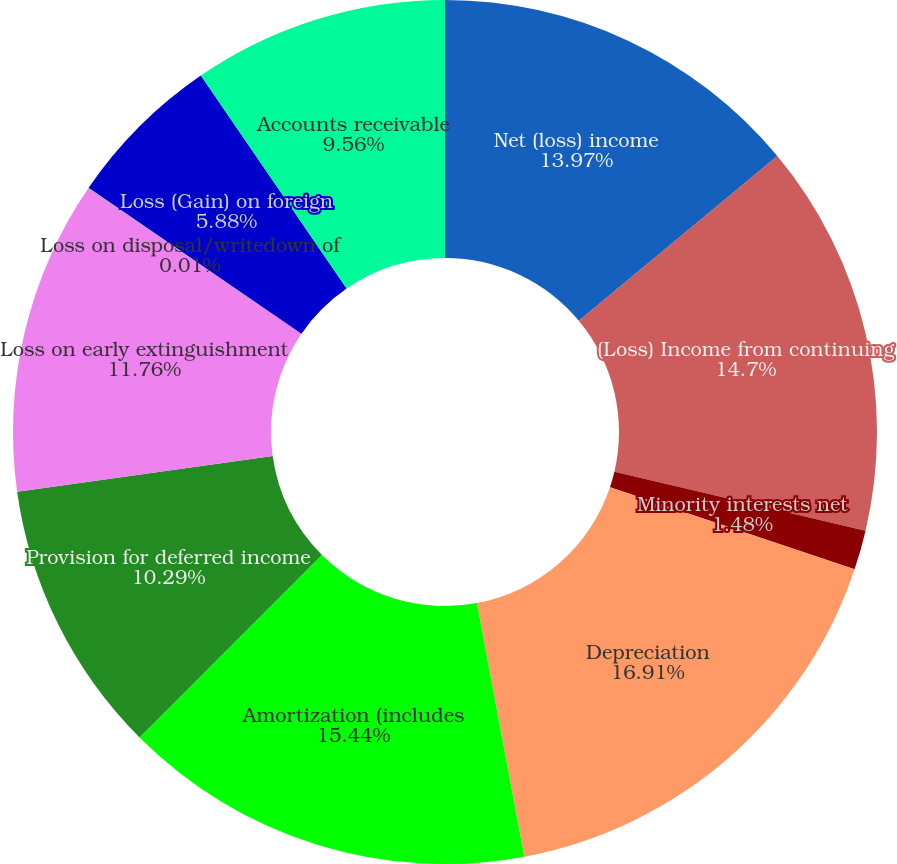Convert chart to OTSL. <chart><loc_0><loc_0><loc_500><loc_500><pie_chart><fcel>Net (loss) income<fcel>(Loss) Income from continuing<fcel>Minority interests net<fcel>Depreciation<fcel>Amortization (includes<fcel>Provision for deferred income<fcel>Loss on early extinguishment<fcel>Loss on disposal/writedown of<fcel>Loss (Gain) on foreign<fcel>Accounts receivable<nl><fcel>13.97%<fcel>14.7%<fcel>1.48%<fcel>16.91%<fcel>15.44%<fcel>10.29%<fcel>11.76%<fcel>0.01%<fcel>5.88%<fcel>9.56%<nl></chart> 